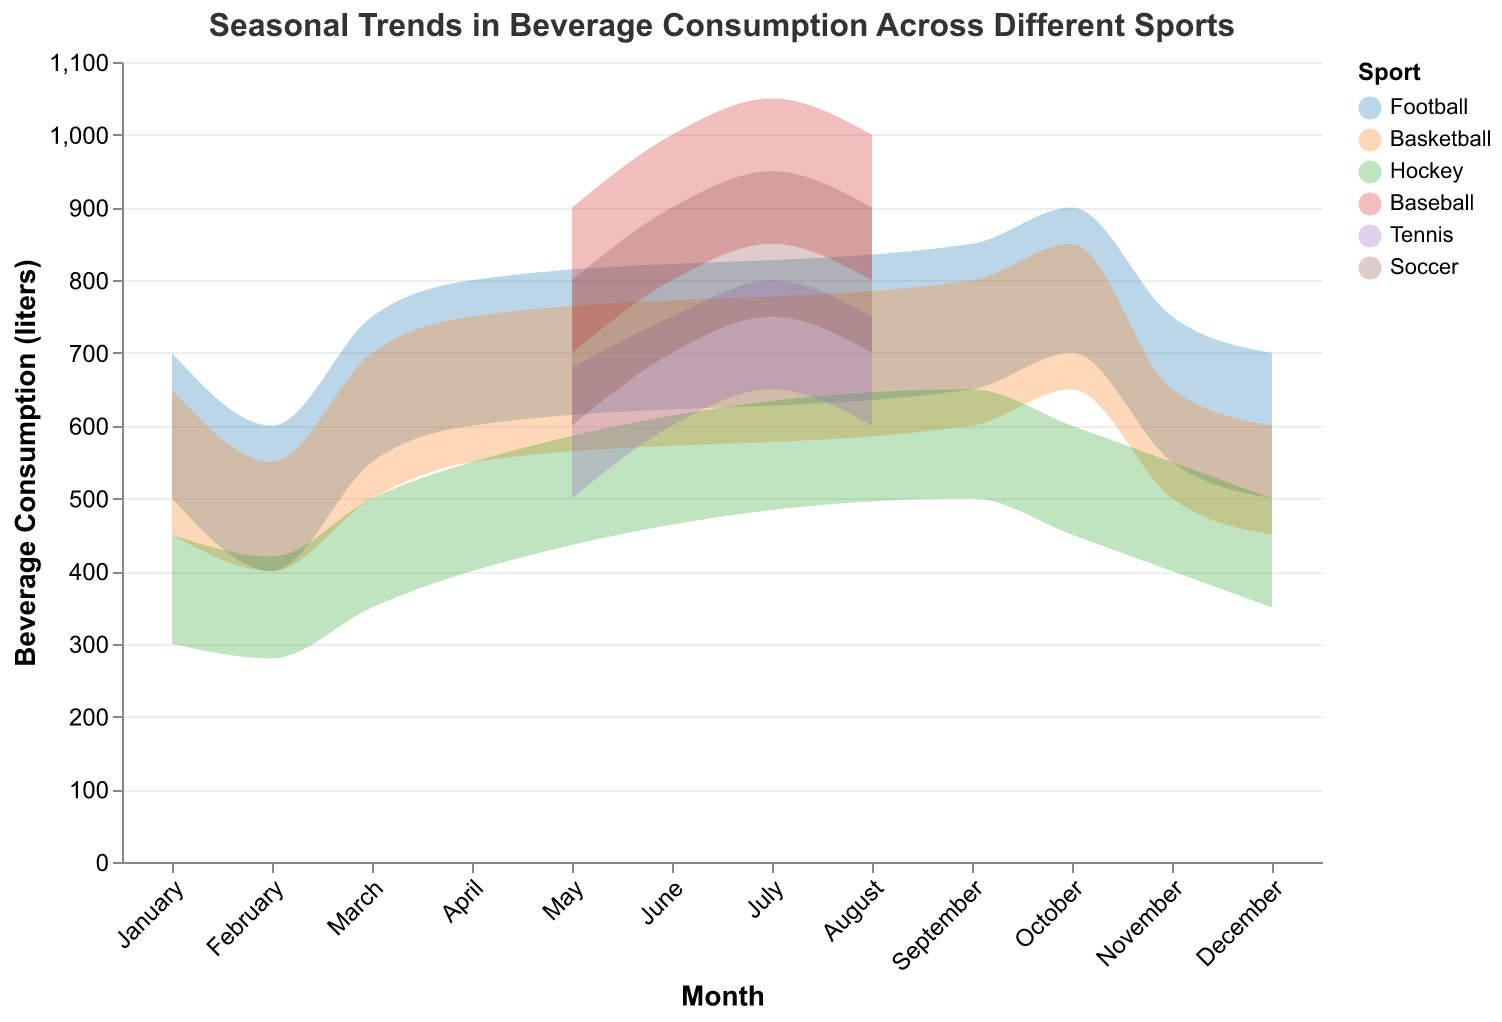What's the highest beverage consumption for Football in March? According to the chart, the highest beverage consumption for Football in March is indicated by the upper edge of the range area for March in the Football color, which is 750 liters.
Answer: 750 liters During which month does Baseball have the highest beverage consumption? Observe the chart and note the maximum values for Baseball across all months. The highest beverage consumption for Baseball is in July, with the range extending up to 1050 liters.
Answer: July How does the beverage consumption for Soccer in June compare to the consumption in May? For Soccer, check the maximum and minimum values for both May and June. In May, the range is 600-800 liters, and in June, it is 700-900 liters. The consumption in June is higher.
Answer: Higher in June Which sport has the widest range of beverage consumption in any month? By comparing all the ranges visually, Baseball in July has the widest range with a spread of 200 liters, from 850 to 1050 liters.
Answer: Baseball in July What is the minimum beverage consumption for Hockey in October? The minimum value for Hockey in October can be found at the lower edge of the range area for October in the Hockey color, which is 450 liters.
Answer: 450 liters Calculate the average maximum beverage consumption across Basketball in October and November. First, identify the maximum values for Basketball in October and November: October is 850 liters, and November is 650 liters. The average is calculated as (850 + 650)/2 = 750 liters.
Answer: 750 liters Does the beverage consumption for Tennis show any increasing trend from June to July? For Tennis, observe the range values from June (600-750 liters) to July (650-800 liters). The ranges are increasing, indicating an upward trend.
Answer: Yes, an increasing trend Which month has the lowest minimum beverage consumption for any sport? Look at the minimum values across all sports and all months. The lowest minimum value is for Hockey in February, which is 280 liters.
Answer: February for Hockey 